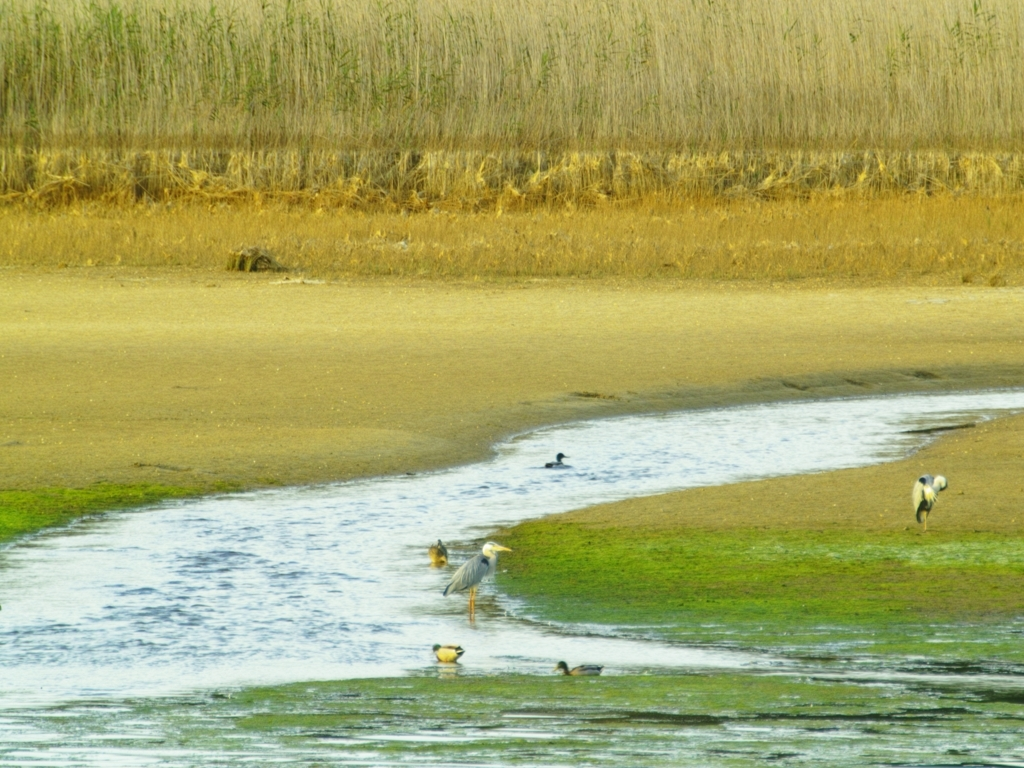What time of day or year does this image suggest? The image seems to be taken during the day, as evident from the daylight and shadows cast by the birds. As for the season, the presence of dry reeds and the level of water suggest it might be late summer or early autumn, a time when water levels in wetlands can recede. 